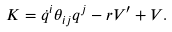Convert formula to latex. <formula><loc_0><loc_0><loc_500><loc_500>K = \dot { q } ^ { i } \theta _ { i j } q ^ { j } - r V ^ { \prime } + V .</formula> 